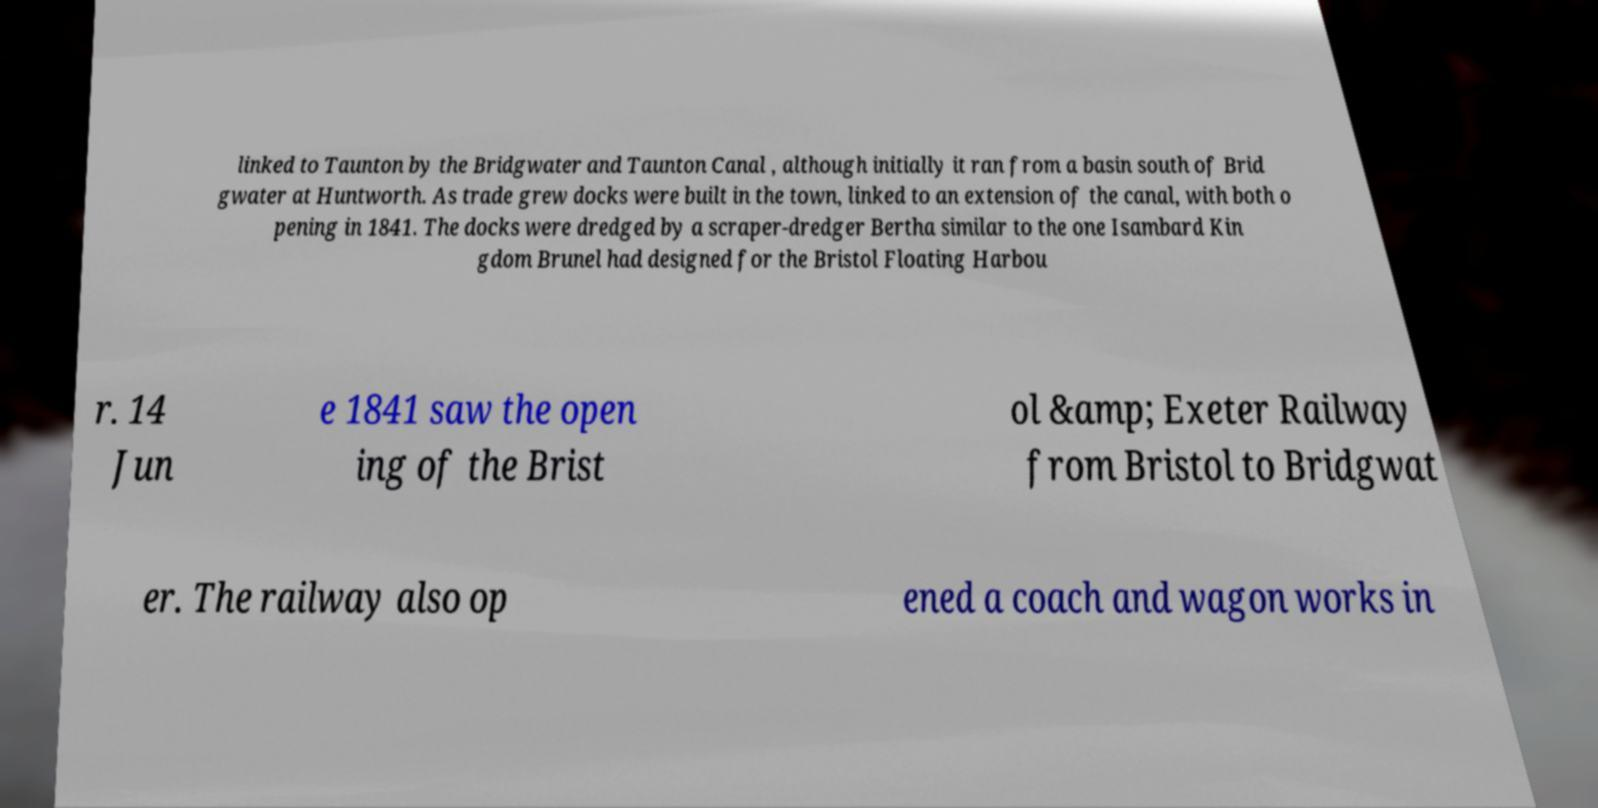I need the written content from this picture converted into text. Can you do that? linked to Taunton by the Bridgwater and Taunton Canal , although initially it ran from a basin south of Brid gwater at Huntworth. As trade grew docks were built in the town, linked to an extension of the canal, with both o pening in 1841. The docks were dredged by a scraper-dredger Bertha similar to the one Isambard Kin gdom Brunel had designed for the Bristol Floating Harbou r. 14 Jun e 1841 saw the open ing of the Brist ol &amp; Exeter Railway from Bristol to Bridgwat er. The railway also op ened a coach and wagon works in 